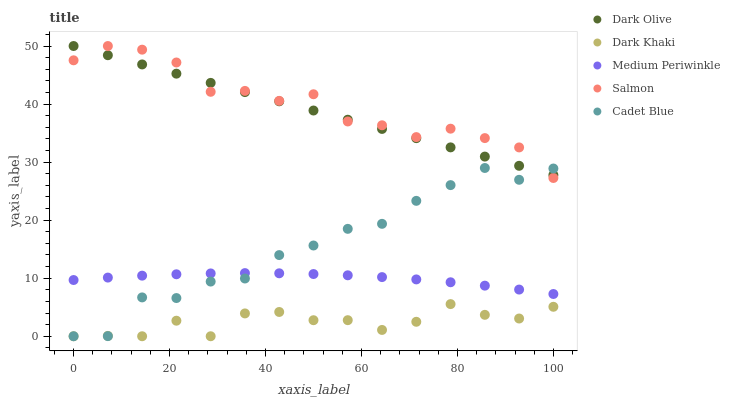Does Dark Khaki have the minimum area under the curve?
Answer yes or no. Yes. Does Salmon have the maximum area under the curve?
Answer yes or no. Yes. Does Dark Olive have the minimum area under the curve?
Answer yes or no. No. Does Dark Olive have the maximum area under the curve?
Answer yes or no. No. Is Dark Olive the smoothest?
Answer yes or no. Yes. Is Cadet Blue the roughest?
Answer yes or no. Yes. Is Salmon the smoothest?
Answer yes or no. No. Is Salmon the roughest?
Answer yes or no. No. Does Dark Khaki have the lowest value?
Answer yes or no. Yes. Does Salmon have the lowest value?
Answer yes or no. No. Does Dark Olive have the highest value?
Answer yes or no. Yes. Does Medium Periwinkle have the highest value?
Answer yes or no. No. Is Dark Khaki less than Medium Periwinkle?
Answer yes or no. Yes. Is Dark Olive greater than Medium Periwinkle?
Answer yes or no. Yes. Does Dark Olive intersect Salmon?
Answer yes or no. Yes. Is Dark Olive less than Salmon?
Answer yes or no. No. Is Dark Olive greater than Salmon?
Answer yes or no. No. Does Dark Khaki intersect Medium Periwinkle?
Answer yes or no. No. 